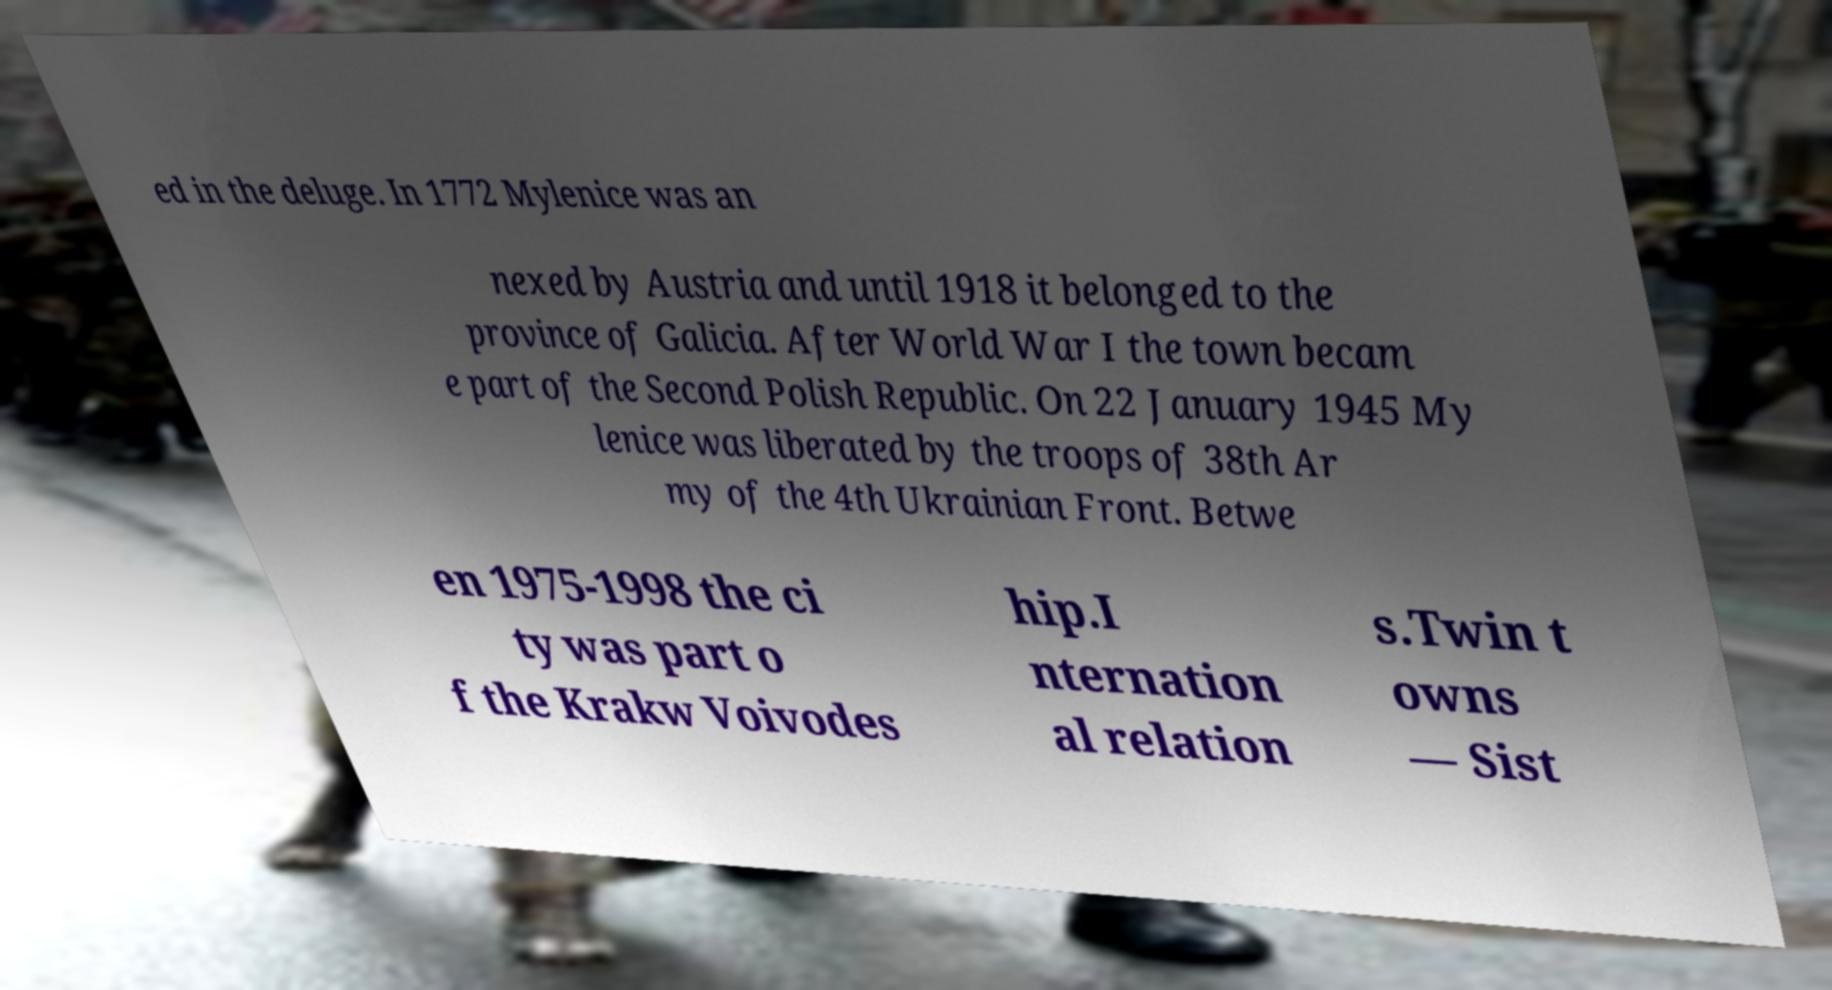There's text embedded in this image that I need extracted. Can you transcribe it verbatim? ed in the deluge. In 1772 Mylenice was an nexed by Austria and until 1918 it belonged to the province of Galicia. After World War I the town becam e part of the Second Polish Republic. On 22 January 1945 My lenice was liberated by the troops of 38th Ar my of the 4th Ukrainian Front. Betwe en 1975-1998 the ci ty was part o f the Krakw Voivodes hip.I nternation al relation s.Twin t owns — Sist 